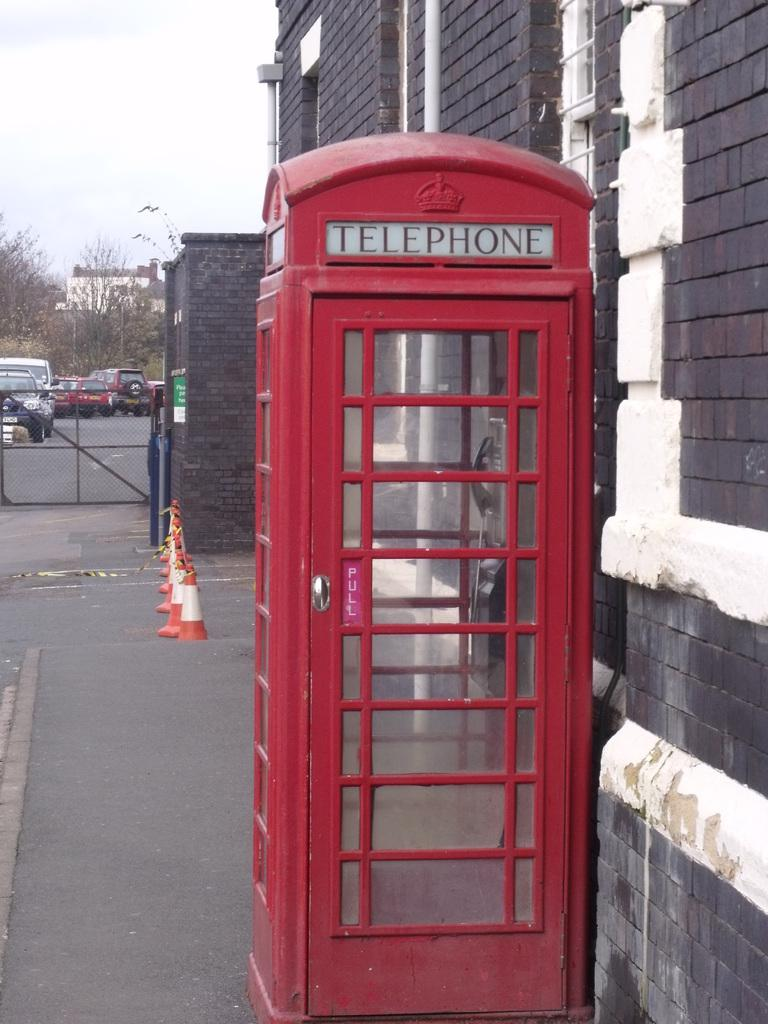<image>
Describe the image concisely. A red telephone booth like the one in Dr Strange on the sidewalk. 